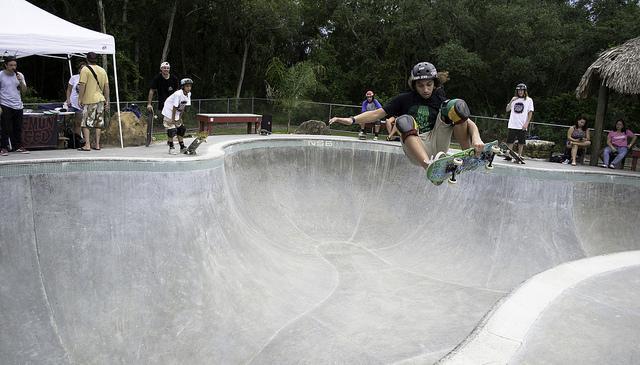How many people are there?
Give a very brief answer. 3. 